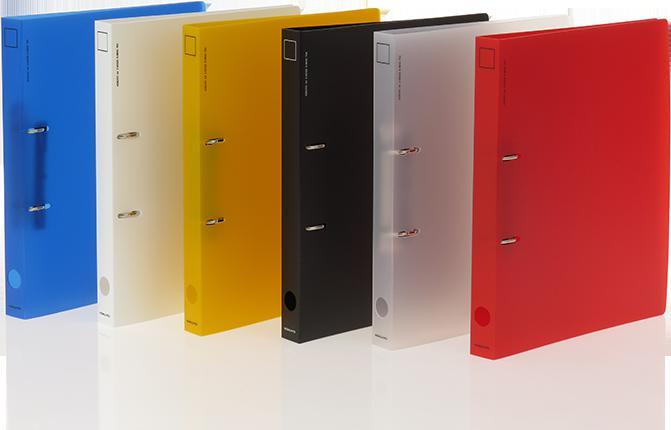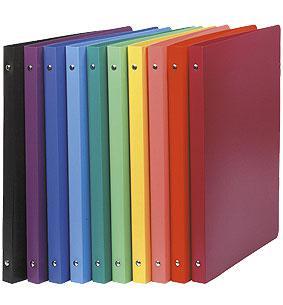The first image is the image on the left, the second image is the image on the right. Examine the images to the left and right. Is the description "There is one clear folder present." accurate? Answer yes or no. Yes. The first image is the image on the left, the second image is the image on the right. For the images displayed, is the sentence "There are nine binders, all appearing to be different colors." factually correct? Answer yes or no. No. 